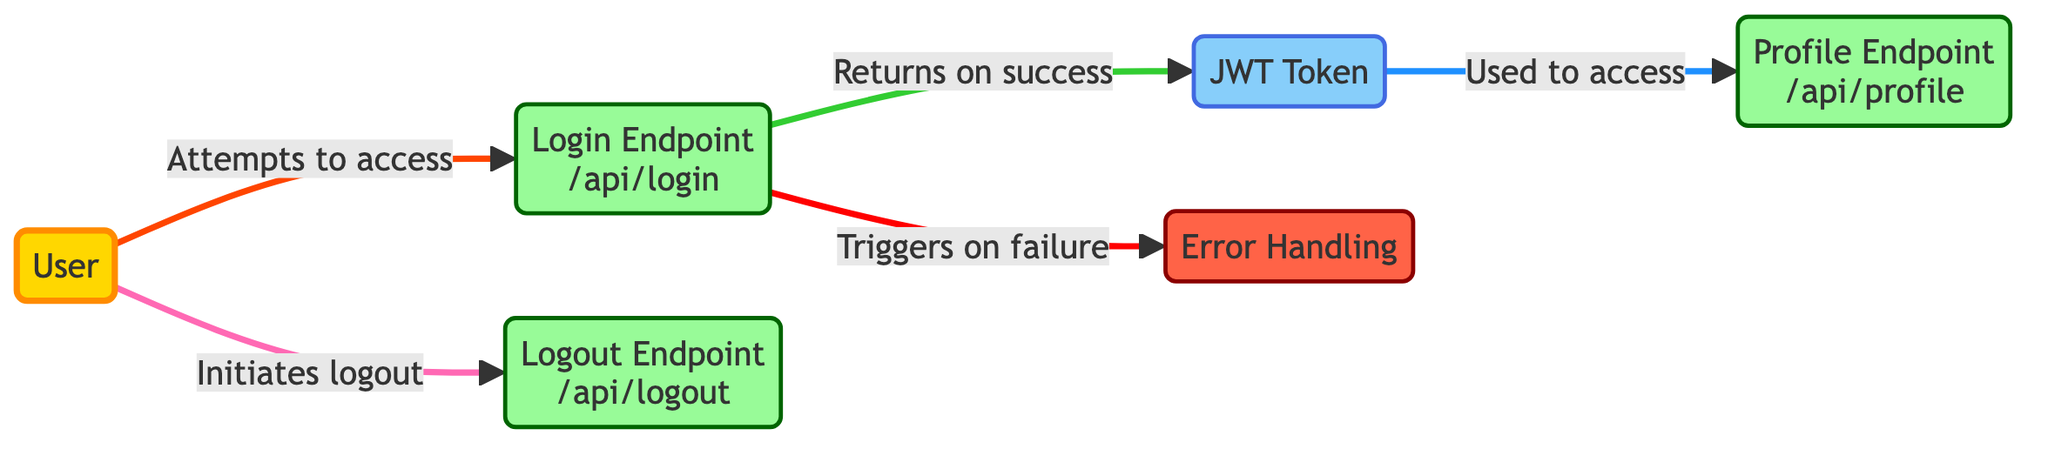What is the total number of nodes in the diagram? The diagram contains six different entities, which are: User, Login Endpoint, JWT Token, Profile Endpoint, Logout Endpoint, and Error Handling. Counting these entities gives a total of six nodes.
Answer: 6 What is the label of the endpoint where users authenticate? The diagram specifies the Login Endpoint as "/api/login," which is the place where users attempt to authenticate and obtain their JWT Token.
Answer: Login Endpoint (/api/login) How many edges are there in the diagram? The diagram has five edges representing the interactions among the nodes: User to Login, Login to Token, Token to Profile, User to Logout, and Login to Error. Counting these connections results in five edges.
Answer: 5 What is the output of the Login Endpoint on success? The Login Endpoint is connected to the JWT Token node with a label stating "Returns on success," indicating that upon successful login, it outputs a JWT Token.
Answer: JWT Token Which node is accessed using the JWT Token? The arrow from the JWT Token node points to the Profile Endpoint, labelled "Used to access," showing that the token is required to access user profile information.
Answer: Profile Endpoint (/api/profile) What happens when the Login Endpoint fails? The edge pointing from the Login Endpoint to the Error Handling node is labelled "Triggers on failure," indicating that an error handling mechanism is activated whenever the login attempt is unsuccessful.
Answer: Error Handling Does the User directly interact with the Profile Endpoint? The diagram shows that the User does not connect directly to the Profile Endpoint; instead, they access it via the JWT Token, which is essential for that access.
Answer: No Which node indicates the process for ending a session? The Logout node is marked as the "Logout Endpoint (/api/logout)" and is directly connected to the User node with the label "Initiates logout," indicating that it is responsible for ending the user's session.
Answer: Logout Endpoint (/api/logout) What type of graph is represented in this diagram? The diagram is a directed graph, meaning it shows the direction of the flow of access and returns between the entities through arrows.
Answer: Directed Graph 